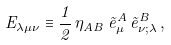<formula> <loc_0><loc_0><loc_500><loc_500>E _ { \lambda \mu \nu } \equiv \frac { 1 } { 2 } \, \eta _ { A B } \, \tilde { e } _ { \mu } ^ { A } \, \tilde { e } _ { \nu ; \lambda } ^ { B } \, ,</formula> 